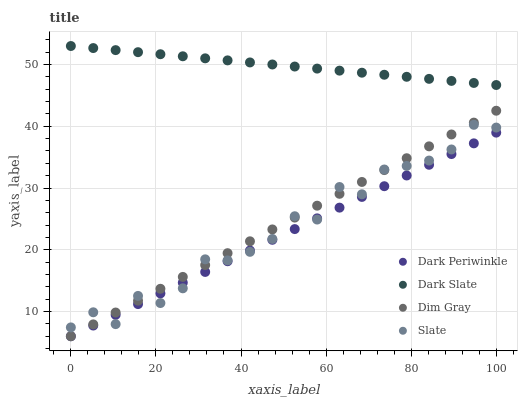Does Dark Periwinkle have the minimum area under the curve?
Answer yes or no. Yes. Does Dark Slate have the maximum area under the curve?
Answer yes or no. Yes. Does Slate have the minimum area under the curve?
Answer yes or no. No. Does Slate have the maximum area under the curve?
Answer yes or no. No. Is Dim Gray the smoothest?
Answer yes or no. Yes. Is Slate the roughest?
Answer yes or no. Yes. Is Slate the smoothest?
Answer yes or no. No. Is Dim Gray the roughest?
Answer yes or no. No. Does Dim Gray have the lowest value?
Answer yes or no. Yes. Does Slate have the lowest value?
Answer yes or no. No. Does Dark Slate have the highest value?
Answer yes or no. Yes. Does Slate have the highest value?
Answer yes or no. No. Is Dim Gray less than Dark Slate?
Answer yes or no. Yes. Is Dark Slate greater than Slate?
Answer yes or no. Yes. Does Dim Gray intersect Slate?
Answer yes or no. Yes. Is Dim Gray less than Slate?
Answer yes or no. No. Is Dim Gray greater than Slate?
Answer yes or no. No. Does Dim Gray intersect Dark Slate?
Answer yes or no. No. 